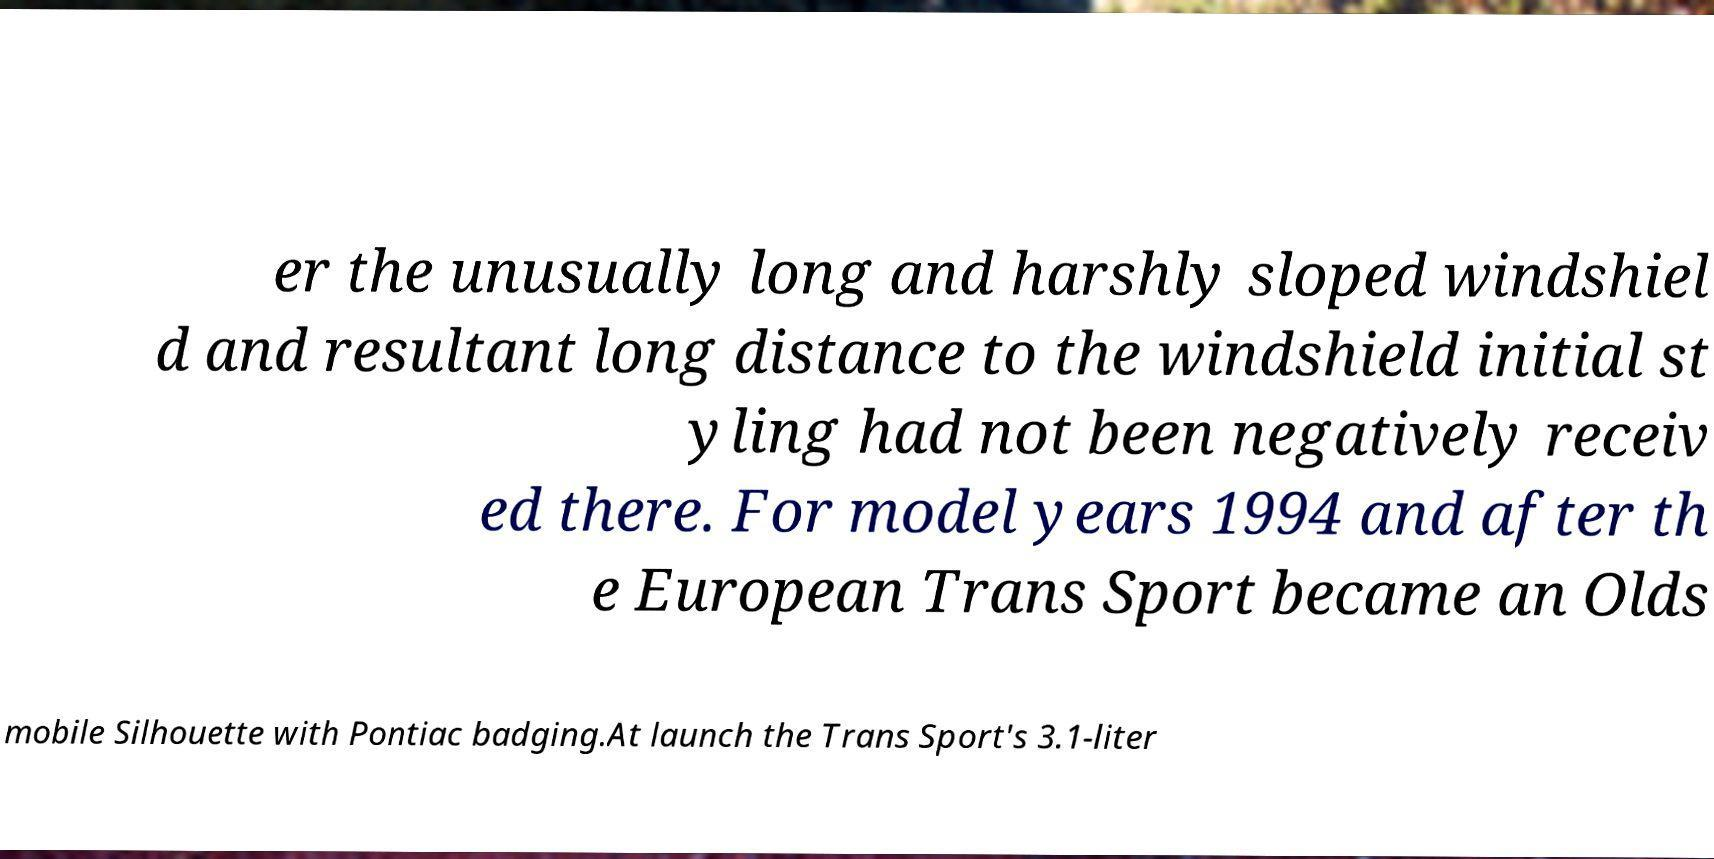Can you read and provide the text displayed in the image?This photo seems to have some interesting text. Can you extract and type it out for me? er the unusually long and harshly sloped windshiel d and resultant long distance to the windshield initial st yling had not been negatively receiv ed there. For model years 1994 and after th e European Trans Sport became an Olds mobile Silhouette with Pontiac badging.At launch the Trans Sport's 3.1-liter 